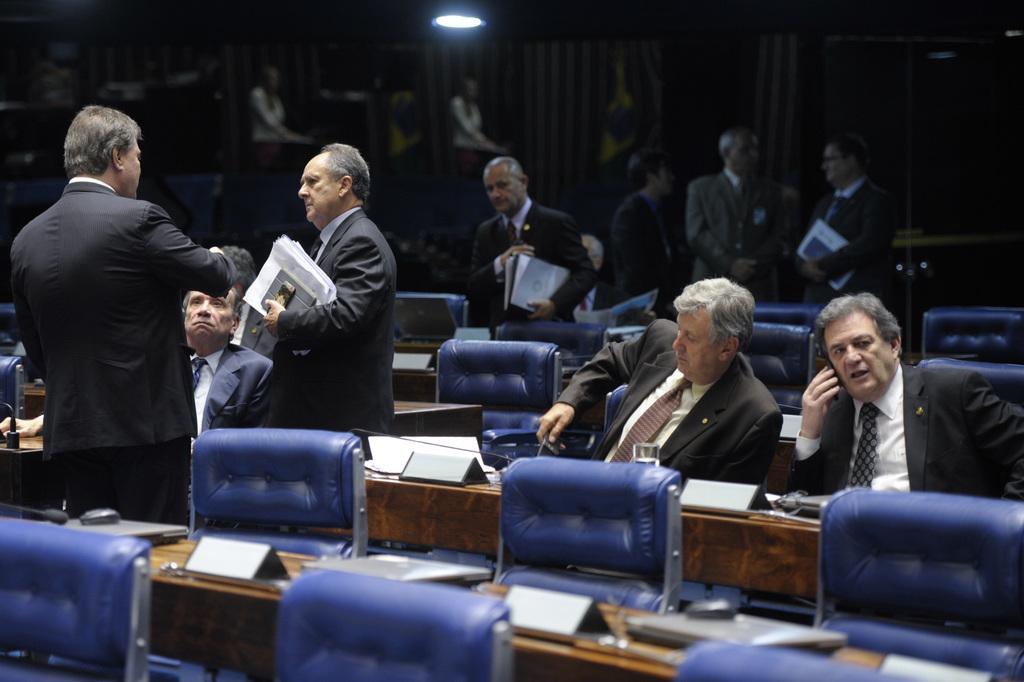Describe this image in one or two sentences. In this image, there are few people sitting on the chairs and I can see few people standing and holding the papers There are name boards, laptops and few other objects on the tables. At the top of the image, there is light. In the background, those are looking like the sculptures and flags. 